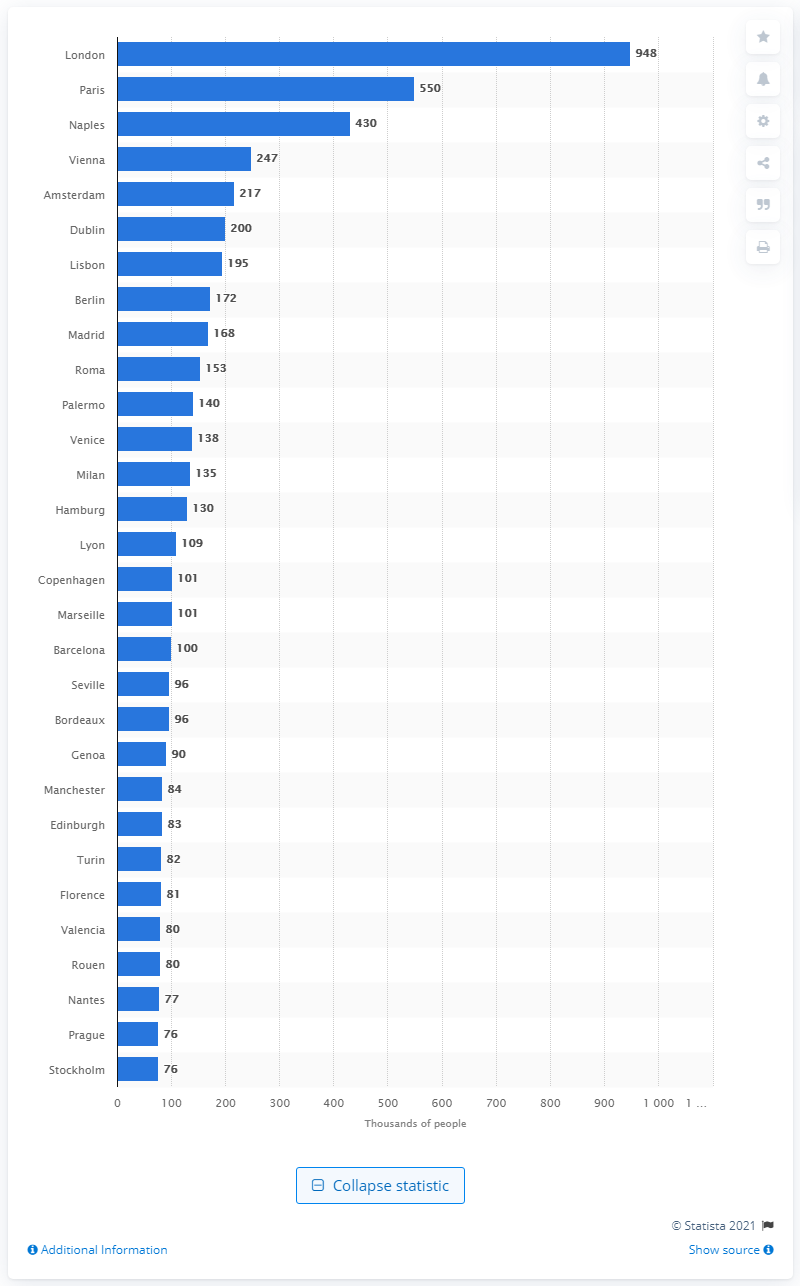What was the largest city in Western Europe in 1800?
 London 